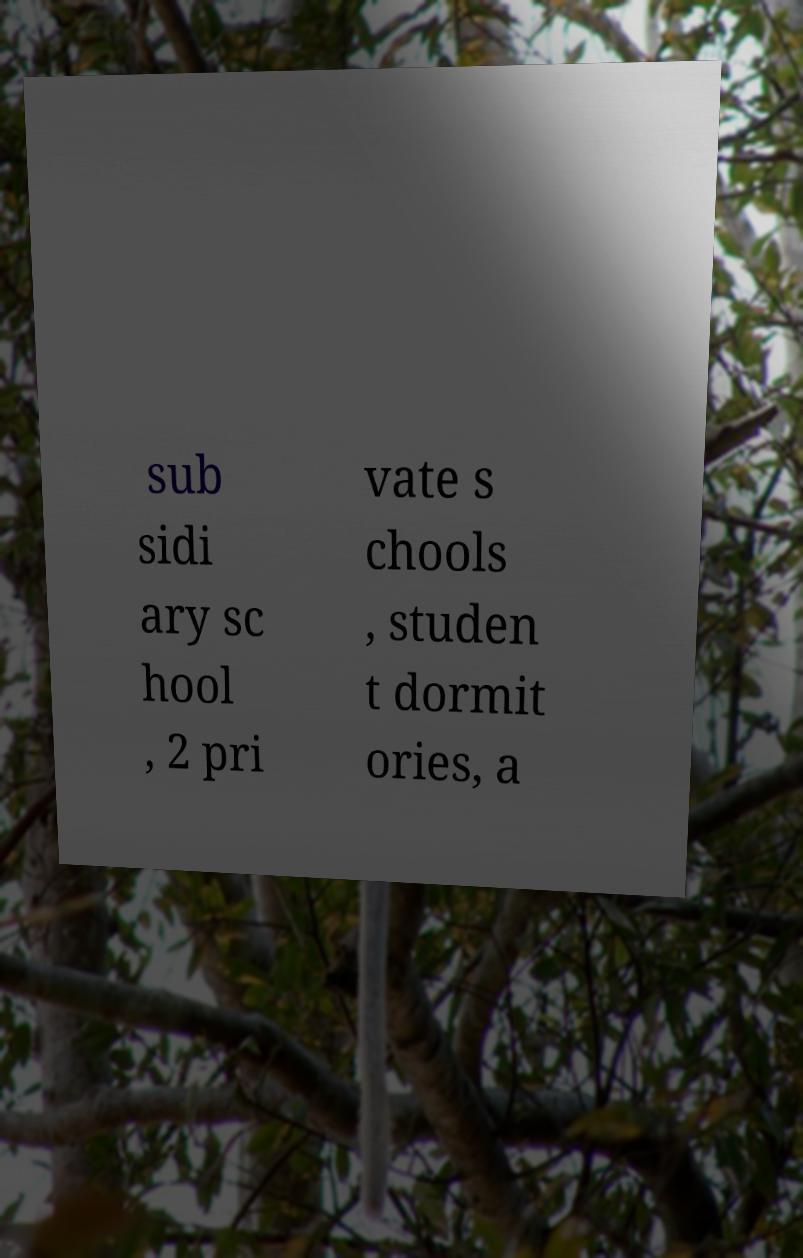What messages or text are displayed in this image? I need them in a readable, typed format. sub sidi ary sc hool , 2 pri vate s chools , studen t dormit ories, a 